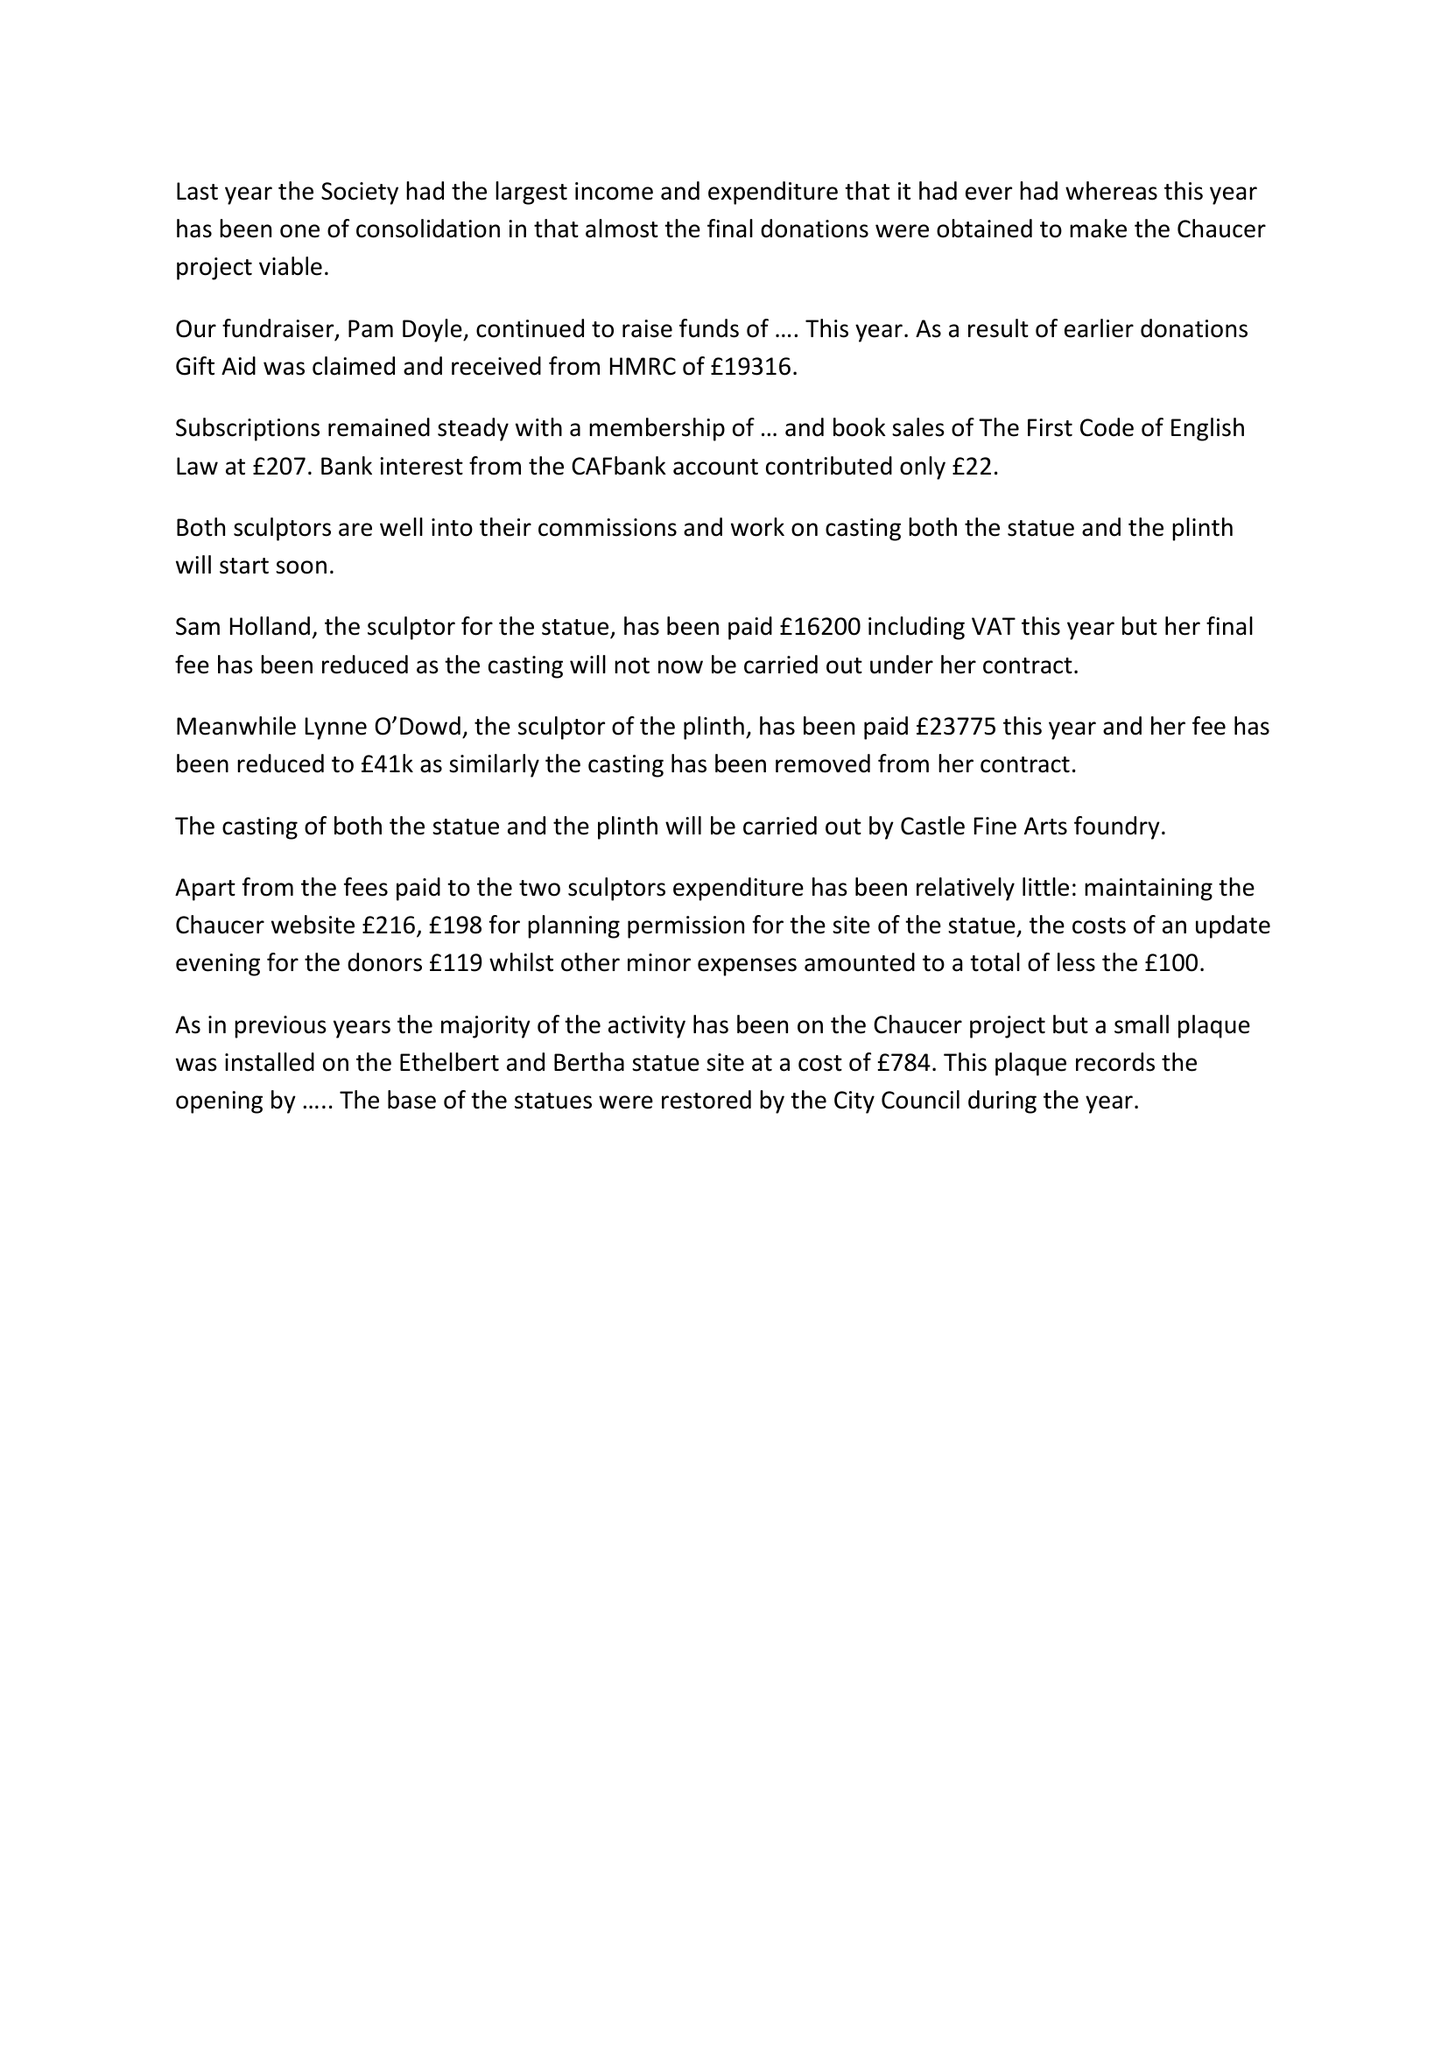What is the value for the report_date?
Answer the question using a single word or phrase. 2016-02-28 